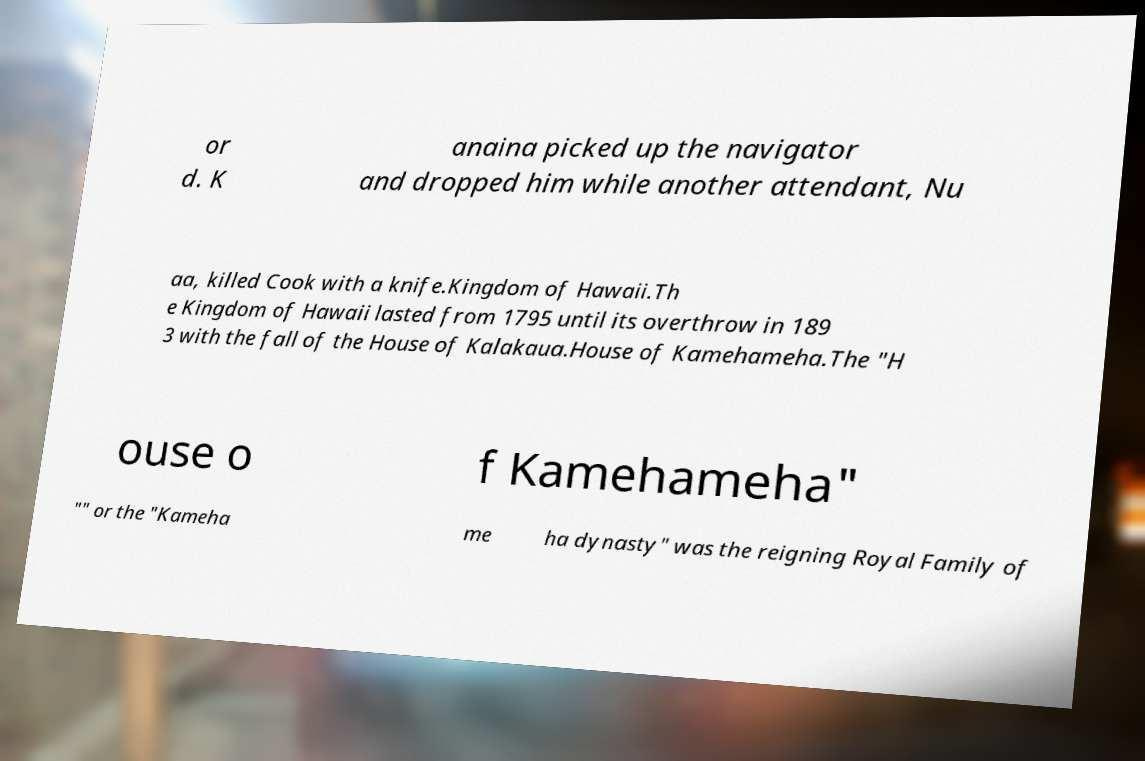Can you accurately transcribe the text from the provided image for me? or d. K anaina picked up the navigator and dropped him while another attendant, Nu aa, killed Cook with a knife.Kingdom of Hawaii.Th e Kingdom of Hawaii lasted from 1795 until its overthrow in 189 3 with the fall of the House of Kalakaua.House of Kamehameha.The "H ouse o f Kamehameha" "" or the "Kameha me ha dynasty" was the reigning Royal Family of 